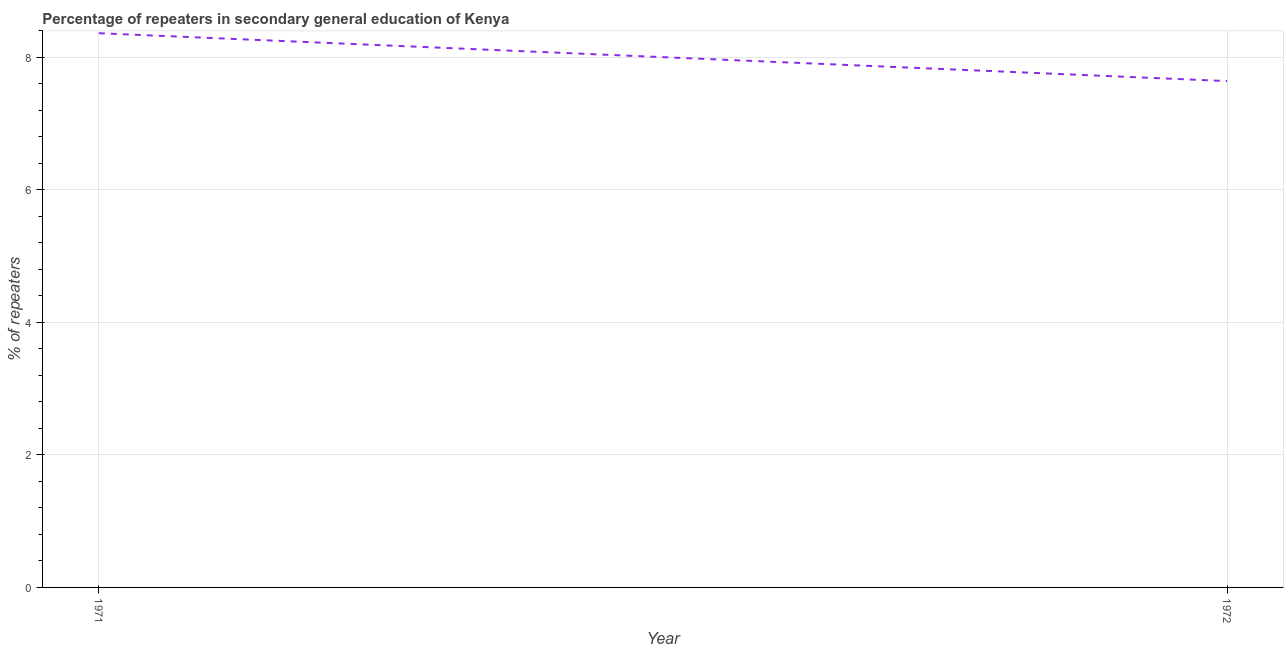What is the percentage of repeaters in 1972?
Your response must be concise. 7.64. Across all years, what is the maximum percentage of repeaters?
Your response must be concise. 8.36. Across all years, what is the minimum percentage of repeaters?
Ensure brevity in your answer.  7.64. What is the sum of the percentage of repeaters?
Give a very brief answer. 16.01. What is the difference between the percentage of repeaters in 1971 and 1972?
Offer a terse response. 0.72. What is the average percentage of repeaters per year?
Your answer should be compact. 8. What is the median percentage of repeaters?
Make the answer very short. 8. Do a majority of the years between 1971 and 1972 (inclusive) have percentage of repeaters greater than 6 %?
Ensure brevity in your answer.  Yes. What is the ratio of the percentage of repeaters in 1971 to that in 1972?
Give a very brief answer. 1.09. In how many years, is the percentage of repeaters greater than the average percentage of repeaters taken over all years?
Offer a very short reply. 1. How many lines are there?
Offer a very short reply. 1. What is the difference between two consecutive major ticks on the Y-axis?
Your response must be concise. 2. Does the graph contain any zero values?
Provide a succinct answer. No. Does the graph contain grids?
Your response must be concise. Yes. What is the title of the graph?
Your answer should be compact. Percentage of repeaters in secondary general education of Kenya. What is the label or title of the Y-axis?
Provide a short and direct response. % of repeaters. What is the % of repeaters of 1971?
Give a very brief answer. 8.36. What is the % of repeaters of 1972?
Offer a terse response. 7.64. What is the difference between the % of repeaters in 1971 and 1972?
Give a very brief answer. 0.72. What is the ratio of the % of repeaters in 1971 to that in 1972?
Your response must be concise. 1.09. 